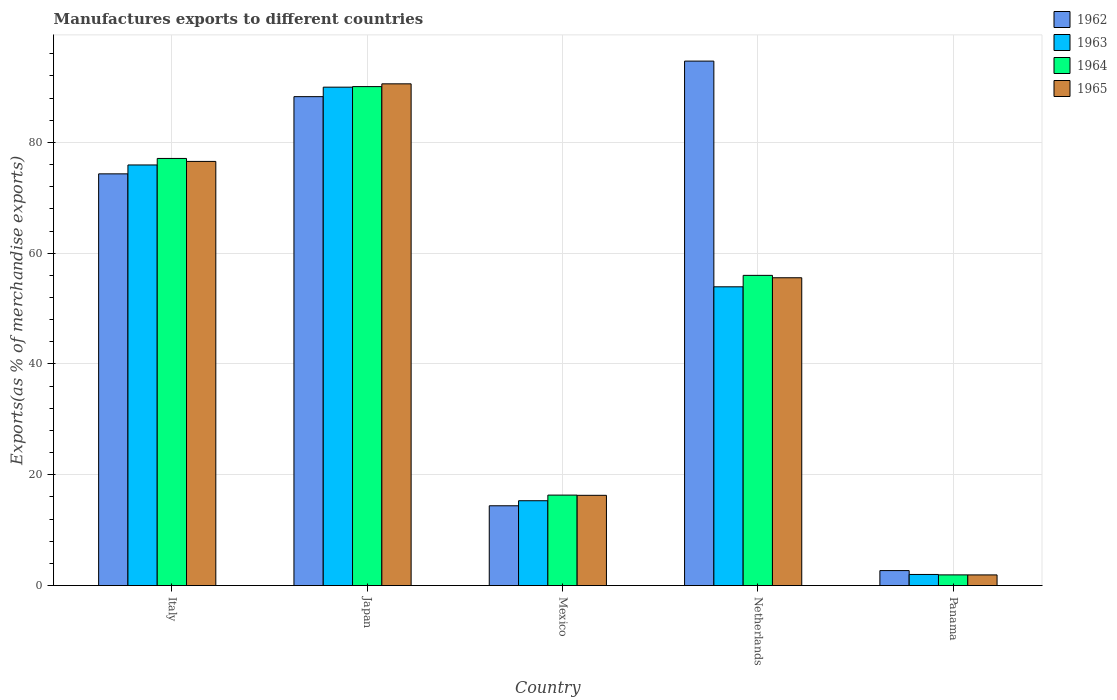How many different coloured bars are there?
Your answer should be very brief. 4. How many groups of bars are there?
Ensure brevity in your answer.  5. Are the number of bars per tick equal to the number of legend labels?
Provide a short and direct response. Yes. How many bars are there on the 4th tick from the right?
Keep it short and to the point. 4. What is the label of the 3rd group of bars from the left?
Provide a short and direct response. Mexico. What is the percentage of exports to different countries in 1965 in Mexico?
Offer a very short reply. 16.29. Across all countries, what is the maximum percentage of exports to different countries in 1964?
Keep it short and to the point. 90.07. Across all countries, what is the minimum percentage of exports to different countries in 1963?
Make the answer very short. 2. In which country was the percentage of exports to different countries in 1965 maximum?
Give a very brief answer. Japan. In which country was the percentage of exports to different countries in 1962 minimum?
Make the answer very short. Panama. What is the total percentage of exports to different countries in 1965 in the graph?
Your answer should be very brief. 240.92. What is the difference between the percentage of exports to different countries in 1964 in Mexico and that in Panama?
Provide a short and direct response. 14.4. What is the difference between the percentage of exports to different countries in 1964 in Panama and the percentage of exports to different countries in 1962 in Japan?
Your response must be concise. -86.33. What is the average percentage of exports to different countries in 1962 per country?
Your answer should be compact. 54.87. What is the difference between the percentage of exports to different countries of/in 1963 and percentage of exports to different countries of/in 1965 in Panama?
Your answer should be compact. 0.08. What is the ratio of the percentage of exports to different countries in 1964 in Netherlands to that in Panama?
Make the answer very short. 29.06. Is the percentage of exports to different countries in 1964 in Italy less than that in Japan?
Ensure brevity in your answer.  Yes. What is the difference between the highest and the second highest percentage of exports to different countries in 1965?
Ensure brevity in your answer.  14.01. What is the difference between the highest and the lowest percentage of exports to different countries in 1964?
Give a very brief answer. 88.15. Is the sum of the percentage of exports to different countries in 1962 in Italy and Japan greater than the maximum percentage of exports to different countries in 1963 across all countries?
Offer a terse response. Yes. Is it the case that in every country, the sum of the percentage of exports to different countries in 1963 and percentage of exports to different countries in 1962 is greater than the sum of percentage of exports to different countries in 1965 and percentage of exports to different countries in 1964?
Your answer should be compact. No. What does the 1st bar from the right in Panama represents?
Provide a short and direct response. 1965. How many bars are there?
Offer a terse response. 20. What is the difference between two consecutive major ticks on the Y-axis?
Keep it short and to the point. 20. Does the graph contain any zero values?
Offer a terse response. No. Does the graph contain grids?
Keep it short and to the point. Yes. Where does the legend appear in the graph?
Provide a short and direct response. Top right. How many legend labels are there?
Ensure brevity in your answer.  4. How are the legend labels stacked?
Keep it short and to the point. Vertical. What is the title of the graph?
Your answer should be very brief. Manufactures exports to different countries. What is the label or title of the Y-axis?
Your answer should be compact. Exports(as % of merchandise exports). What is the Exports(as % of merchandise exports) in 1962 in Italy?
Ensure brevity in your answer.  74.32. What is the Exports(as % of merchandise exports) in 1963 in Italy?
Give a very brief answer. 75.93. What is the Exports(as % of merchandise exports) of 1964 in Italy?
Keep it short and to the point. 77.1. What is the Exports(as % of merchandise exports) of 1965 in Italy?
Provide a short and direct response. 76.57. What is the Exports(as % of merchandise exports) of 1962 in Japan?
Provide a succinct answer. 88.26. What is the Exports(as % of merchandise exports) of 1963 in Japan?
Ensure brevity in your answer.  89.97. What is the Exports(as % of merchandise exports) of 1964 in Japan?
Make the answer very short. 90.07. What is the Exports(as % of merchandise exports) in 1965 in Japan?
Keep it short and to the point. 90.57. What is the Exports(as % of merchandise exports) in 1962 in Mexico?
Make the answer very short. 14.4. What is the Exports(as % of merchandise exports) in 1963 in Mexico?
Your answer should be compact. 15.31. What is the Exports(as % of merchandise exports) in 1964 in Mexico?
Provide a short and direct response. 16.33. What is the Exports(as % of merchandise exports) of 1965 in Mexico?
Make the answer very short. 16.29. What is the Exports(as % of merchandise exports) of 1962 in Netherlands?
Make the answer very short. 94.68. What is the Exports(as % of merchandise exports) of 1963 in Netherlands?
Provide a succinct answer. 53.93. What is the Exports(as % of merchandise exports) of 1964 in Netherlands?
Provide a short and direct response. 56. What is the Exports(as % of merchandise exports) of 1965 in Netherlands?
Ensure brevity in your answer.  55.57. What is the Exports(as % of merchandise exports) of 1962 in Panama?
Give a very brief answer. 2.7. What is the Exports(as % of merchandise exports) in 1963 in Panama?
Ensure brevity in your answer.  2. What is the Exports(as % of merchandise exports) of 1964 in Panama?
Provide a short and direct response. 1.93. What is the Exports(as % of merchandise exports) of 1965 in Panama?
Provide a succinct answer. 1.92. Across all countries, what is the maximum Exports(as % of merchandise exports) of 1962?
Offer a very short reply. 94.68. Across all countries, what is the maximum Exports(as % of merchandise exports) in 1963?
Keep it short and to the point. 89.97. Across all countries, what is the maximum Exports(as % of merchandise exports) in 1964?
Your answer should be very brief. 90.07. Across all countries, what is the maximum Exports(as % of merchandise exports) in 1965?
Your answer should be very brief. 90.57. Across all countries, what is the minimum Exports(as % of merchandise exports) in 1962?
Offer a very short reply. 2.7. Across all countries, what is the minimum Exports(as % of merchandise exports) of 1963?
Your response must be concise. 2. Across all countries, what is the minimum Exports(as % of merchandise exports) in 1964?
Your answer should be very brief. 1.93. Across all countries, what is the minimum Exports(as % of merchandise exports) of 1965?
Your response must be concise. 1.92. What is the total Exports(as % of merchandise exports) of 1962 in the graph?
Your response must be concise. 274.37. What is the total Exports(as % of merchandise exports) of 1963 in the graph?
Give a very brief answer. 237.15. What is the total Exports(as % of merchandise exports) in 1964 in the graph?
Provide a succinct answer. 241.43. What is the total Exports(as % of merchandise exports) in 1965 in the graph?
Provide a succinct answer. 240.92. What is the difference between the Exports(as % of merchandise exports) of 1962 in Italy and that in Japan?
Keep it short and to the point. -13.94. What is the difference between the Exports(as % of merchandise exports) of 1963 in Italy and that in Japan?
Provide a short and direct response. -14.04. What is the difference between the Exports(as % of merchandise exports) in 1964 in Italy and that in Japan?
Provide a succinct answer. -12.97. What is the difference between the Exports(as % of merchandise exports) in 1965 in Italy and that in Japan?
Your response must be concise. -14.01. What is the difference between the Exports(as % of merchandise exports) of 1962 in Italy and that in Mexico?
Offer a terse response. 59.92. What is the difference between the Exports(as % of merchandise exports) of 1963 in Italy and that in Mexico?
Provide a short and direct response. 60.61. What is the difference between the Exports(as % of merchandise exports) in 1964 in Italy and that in Mexico?
Provide a succinct answer. 60.77. What is the difference between the Exports(as % of merchandise exports) of 1965 in Italy and that in Mexico?
Make the answer very short. 60.28. What is the difference between the Exports(as % of merchandise exports) in 1962 in Italy and that in Netherlands?
Keep it short and to the point. -20.36. What is the difference between the Exports(as % of merchandise exports) in 1963 in Italy and that in Netherlands?
Provide a succinct answer. 22. What is the difference between the Exports(as % of merchandise exports) of 1964 in Italy and that in Netherlands?
Provide a succinct answer. 21.11. What is the difference between the Exports(as % of merchandise exports) of 1965 in Italy and that in Netherlands?
Provide a succinct answer. 21. What is the difference between the Exports(as % of merchandise exports) of 1962 in Italy and that in Panama?
Keep it short and to the point. 71.62. What is the difference between the Exports(as % of merchandise exports) of 1963 in Italy and that in Panama?
Give a very brief answer. 73.92. What is the difference between the Exports(as % of merchandise exports) of 1964 in Italy and that in Panama?
Your response must be concise. 75.18. What is the difference between the Exports(as % of merchandise exports) of 1965 in Italy and that in Panama?
Make the answer very short. 74.64. What is the difference between the Exports(as % of merchandise exports) in 1962 in Japan and that in Mexico?
Your answer should be very brief. 73.86. What is the difference between the Exports(as % of merchandise exports) in 1963 in Japan and that in Mexico?
Provide a succinct answer. 74.66. What is the difference between the Exports(as % of merchandise exports) of 1964 in Japan and that in Mexico?
Your answer should be compact. 73.74. What is the difference between the Exports(as % of merchandise exports) of 1965 in Japan and that in Mexico?
Give a very brief answer. 74.28. What is the difference between the Exports(as % of merchandise exports) in 1962 in Japan and that in Netherlands?
Give a very brief answer. -6.42. What is the difference between the Exports(as % of merchandise exports) of 1963 in Japan and that in Netherlands?
Your answer should be compact. 36.04. What is the difference between the Exports(as % of merchandise exports) in 1964 in Japan and that in Netherlands?
Make the answer very short. 34.07. What is the difference between the Exports(as % of merchandise exports) in 1965 in Japan and that in Netherlands?
Your response must be concise. 35.01. What is the difference between the Exports(as % of merchandise exports) in 1962 in Japan and that in Panama?
Give a very brief answer. 85.56. What is the difference between the Exports(as % of merchandise exports) of 1963 in Japan and that in Panama?
Ensure brevity in your answer.  87.97. What is the difference between the Exports(as % of merchandise exports) in 1964 in Japan and that in Panama?
Your response must be concise. 88.15. What is the difference between the Exports(as % of merchandise exports) of 1965 in Japan and that in Panama?
Keep it short and to the point. 88.65. What is the difference between the Exports(as % of merchandise exports) of 1962 in Mexico and that in Netherlands?
Your response must be concise. -80.27. What is the difference between the Exports(as % of merchandise exports) in 1963 in Mexico and that in Netherlands?
Offer a terse response. -38.62. What is the difference between the Exports(as % of merchandise exports) in 1964 in Mexico and that in Netherlands?
Offer a very short reply. -39.67. What is the difference between the Exports(as % of merchandise exports) in 1965 in Mexico and that in Netherlands?
Your answer should be compact. -39.28. What is the difference between the Exports(as % of merchandise exports) in 1962 in Mexico and that in Panama?
Keep it short and to the point. 11.7. What is the difference between the Exports(as % of merchandise exports) of 1963 in Mexico and that in Panama?
Offer a very short reply. 13.31. What is the difference between the Exports(as % of merchandise exports) in 1964 in Mexico and that in Panama?
Provide a succinct answer. 14.4. What is the difference between the Exports(as % of merchandise exports) in 1965 in Mexico and that in Panama?
Ensure brevity in your answer.  14.37. What is the difference between the Exports(as % of merchandise exports) in 1962 in Netherlands and that in Panama?
Provide a succinct answer. 91.97. What is the difference between the Exports(as % of merchandise exports) of 1963 in Netherlands and that in Panama?
Your answer should be very brief. 51.93. What is the difference between the Exports(as % of merchandise exports) in 1964 in Netherlands and that in Panama?
Offer a terse response. 54.07. What is the difference between the Exports(as % of merchandise exports) of 1965 in Netherlands and that in Panama?
Your answer should be very brief. 53.64. What is the difference between the Exports(as % of merchandise exports) in 1962 in Italy and the Exports(as % of merchandise exports) in 1963 in Japan?
Offer a very short reply. -15.65. What is the difference between the Exports(as % of merchandise exports) in 1962 in Italy and the Exports(as % of merchandise exports) in 1964 in Japan?
Give a very brief answer. -15.75. What is the difference between the Exports(as % of merchandise exports) in 1962 in Italy and the Exports(as % of merchandise exports) in 1965 in Japan?
Ensure brevity in your answer.  -16.25. What is the difference between the Exports(as % of merchandise exports) of 1963 in Italy and the Exports(as % of merchandise exports) of 1964 in Japan?
Give a very brief answer. -14.14. What is the difference between the Exports(as % of merchandise exports) of 1963 in Italy and the Exports(as % of merchandise exports) of 1965 in Japan?
Ensure brevity in your answer.  -14.64. What is the difference between the Exports(as % of merchandise exports) of 1964 in Italy and the Exports(as % of merchandise exports) of 1965 in Japan?
Provide a succinct answer. -13.47. What is the difference between the Exports(as % of merchandise exports) in 1962 in Italy and the Exports(as % of merchandise exports) in 1963 in Mexico?
Give a very brief answer. 59.01. What is the difference between the Exports(as % of merchandise exports) in 1962 in Italy and the Exports(as % of merchandise exports) in 1964 in Mexico?
Keep it short and to the point. 57.99. What is the difference between the Exports(as % of merchandise exports) in 1962 in Italy and the Exports(as % of merchandise exports) in 1965 in Mexico?
Ensure brevity in your answer.  58.03. What is the difference between the Exports(as % of merchandise exports) in 1963 in Italy and the Exports(as % of merchandise exports) in 1964 in Mexico?
Your answer should be very brief. 59.6. What is the difference between the Exports(as % of merchandise exports) of 1963 in Italy and the Exports(as % of merchandise exports) of 1965 in Mexico?
Make the answer very short. 59.64. What is the difference between the Exports(as % of merchandise exports) in 1964 in Italy and the Exports(as % of merchandise exports) in 1965 in Mexico?
Your answer should be very brief. 60.81. What is the difference between the Exports(as % of merchandise exports) in 1962 in Italy and the Exports(as % of merchandise exports) in 1963 in Netherlands?
Offer a terse response. 20.39. What is the difference between the Exports(as % of merchandise exports) in 1962 in Italy and the Exports(as % of merchandise exports) in 1964 in Netherlands?
Your response must be concise. 18.32. What is the difference between the Exports(as % of merchandise exports) of 1962 in Italy and the Exports(as % of merchandise exports) of 1965 in Netherlands?
Keep it short and to the point. 18.76. What is the difference between the Exports(as % of merchandise exports) in 1963 in Italy and the Exports(as % of merchandise exports) in 1964 in Netherlands?
Your answer should be compact. 19.93. What is the difference between the Exports(as % of merchandise exports) of 1963 in Italy and the Exports(as % of merchandise exports) of 1965 in Netherlands?
Ensure brevity in your answer.  20.36. What is the difference between the Exports(as % of merchandise exports) of 1964 in Italy and the Exports(as % of merchandise exports) of 1965 in Netherlands?
Offer a very short reply. 21.54. What is the difference between the Exports(as % of merchandise exports) in 1962 in Italy and the Exports(as % of merchandise exports) in 1963 in Panama?
Ensure brevity in your answer.  72.32. What is the difference between the Exports(as % of merchandise exports) in 1962 in Italy and the Exports(as % of merchandise exports) in 1964 in Panama?
Your answer should be compact. 72.39. What is the difference between the Exports(as % of merchandise exports) in 1962 in Italy and the Exports(as % of merchandise exports) in 1965 in Panama?
Your answer should be very brief. 72.4. What is the difference between the Exports(as % of merchandise exports) in 1963 in Italy and the Exports(as % of merchandise exports) in 1964 in Panama?
Make the answer very short. 74. What is the difference between the Exports(as % of merchandise exports) in 1963 in Italy and the Exports(as % of merchandise exports) in 1965 in Panama?
Your response must be concise. 74.01. What is the difference between the Exports(as % of merchandise exports) of 1964 in Italy and the Exports(as % of merchandise exports) of 1965 in Panama?
Offer a very short reply. 75.18. What is the difference between the Exports(as % of merchandise exports) of 1962 in Japan and the Exports(as % of merchandise exports) of 1963 in Mexico?
Offer a very short reply. 72.95. What is the difference between the Exports(as % of merchandise exports) in 1962 in Japan and the Exports(as % of merchandise exports) in 1964 in Mexico?
Your response must be concise. 71.93. What is the difference between the Exports(as % of merchandise exports) of 1962 in Japan and the Exports(as % of merchandise exports) of 1965 in Mexico?
Keep it short and to the point. 71.97. What is the difference between the Exports(as % of merchandise exports) of 1963 in Japan and the Exports(as % of merchandise exports) of 1964 in Mexico?
Your response must be concise. 73.64. What is the difference between the Exports(as % of merchandise exports) in 1963 in Japan and the Exports(as % of merchandise exports) in 1965 in Mexico?
Give a very brief answer. 73.68. What is the difference between the Exports(as % of merchandise exports) in 1964 in Japan and the Exports(as % of merchandise exports) in 1965 in Mexico?
Your answer should be very brief. 73.78. What is the difference between the Exports(as % of merchandise exports) of 1962 in Japan and the Exports(as % of merchandise exports) of 1963 in Netherlands?
Give a very brief answer. 34.33. What is the difference between the Exports(as % of merchandise exports) of 1962 in Japan and the Exports(as % of merchandise exports) of 1964 in Netherlands?
Provide a short and direct response. 32.26. What is the difference between the Exports(as % of merchandise exports) of 1962 in Japan and the Exports(as % of merchandise exports) of 1965 in Netherlands?
Your answer should be compact. 32.69. What is the difference between the Exports(as % of merchandise exports) in 1963 in Japan and the Exports(as % of merchandise exports) in 1964 in Netherlands?
Provide a succinct answer. 33.97. What is the difference between the Exports(as % of merchandise exports) of 1963 in Japan and the Exports(as % of merchandise exports) of 1965 in Netherlands?
Your answer should be very brief. 34.41. What is the difference between the Exports(as % of merchandise exports) in 1964 in Japan and the Exports(as % of merchandise exports) in 1965 in Netherlands?
Your answer should be very brief. 34.51. What is the difference between the Exports(as % of merchandise exports) in 1962 in Japan and the Exports(as % of merchandise exports) in 1963 in Panama?
Offer a very short reply. 86.26. What is the difference between the Exports(as % of merchandise exports) of 1962 in Japan and the Exports(as % of merchandise exports) of 1964 in Panama?
Keep it short and to the point. 86.33. What is the difference between the Exports(as % of merchandise exports) of 1962 in Japan and the Exports(as % of merchandise exports) of 1965 in Panama?
Your response must be concise. 86.34. What is the difference between the Exports(as % of merchandise exports) in 1963 in Japan and the Exports(as % of merchandise exports) in 1964 in Panama?
Provide a succinct answer. 88.05. What is the difference between the Exports(as % of merchandise exports) of 1963 in Japan and the Exports(as % of merchandise exports) of 1965 in Panama?
Your answer should be compact. 88.05. What is the difference between the Exports(as % of merchandise exports) of 1964 in Japan and the Exports(as % of merchandise exports) of 1965 in Panama?
Your answer should be compact. 88.15. What is the difference between the Exports(as % of merchandise exports) in 1962 in Mexico and the Exports(as % of merchandise exports) in 1963 in Netherlands?
Provide a short and direct response. -39.53. What is the difference between the Exports(as % of merchandise exports) of 1962 in Mexico and the Exports(as % of merchandise exports) of 1964 in Netherlands?
Your answer should be compact. -41.59. What is the difference between the Exports(as % of merchandise exports) of 1962 in Mexico and the Exports(as % of merchandise exports) of 1965 in Netherlands?
Your response must be concise. -41.16. What is the difference between the Exports(as % of merchandise exports) of 1963 in Mexico and the Exports(as % of merchandise exports) of 1964 in Netherlands?
Your answer should be compact. -40.68. What is the difference between the Exports(as % of merchandise exports) of 1963 in Mexico and the Exports(as % of merchandise exports) of 1965 in Netherlands?
Your answer should be compact. -40.25. What is the difference between the Exports(as % of merchandise exports) of 1964 in Mexico and the Exports(as % of merchandise exports) of 1965 in Netherlands?
Your response must be concise. -39.24. What is the difference between the Exports(as % of merchandise exports) of 1962 in Mexico and the Exports(as % of merchandise exports) of 1963 in Panama?
Ensure brevity in your answer.  12.4. What is the difference between the Exports(as % of merchandise exports) of 1962 in Mexico and the Exports(as % of merchandise exports) of 1964 in Panama?
Offer a terse response. 12.48. What is the difference between the Exports(as % of merchandise exports) of 1962 in Mexico and the Exports(as % of merchandise exports) of 1965 in Panama?
Your answer should be very brief. 12.48. What is the difference between the Exports(as % of merchandise exports) of 1963 in Mexico and the Exports(as % of merchandise exports) of 1964 in Panama?
Ensure brevity in your answer.  13.39. What is the difference between the Exports(as % of merchandise exports) in 1963 in Mexico and the Exports(as % of merchandise exports) in 1965 in Panama?
Make the answer very short. 13.39. What is the difference between the Exports(as % of merchandise exports) in 1964 in Mexico and the Exports(as % of merchandise exports) in 1965 in Panama?
Provide a succinct answer. 14.41. What is the difference between the Exports(as % of merchandise exports) of 1962 in Netherlands and the Exports(as % of merchandise exports) of 1963 in Panama?
Make the answer very short. 92.67. What is the difference between the Exports(as % of merchandise exports) in 1962 in Netherlands and the Exports(as % of merchandise exports) in 1964 in Panama?
Your answer should be compact. 92.75. What is the difference between the Exports(as % of merchandise exports) in 1962 in Netherlands and the Exports(as % of merchandise exports) in 1965 in Panama?
Give a very brief answer. 92.75. What is the difference between the Exports(as % of merchandise exports) in 1963 in Netherlands and the Exports(as % of merchandise exports) in 1964 in Panama?
Keep it short and to the point. 52. What is the difference between the Exports(as % of merchandise exports) in 1963 in Netherlands and the Exports(as % of merchandise exports) in 1965 in Panama?
Make the answer very short. 52.01. What is the difference between the Exports(as % of merchandise exports) in 1964 in Netherlands and the Exports(as % of merchandise exports) in 1965 in Panama?
Offer a very short reply. 54.07. What is the average Exports(as % of merchandise exports) of 1962 per country?
Your response must be concise. 54.87. What is the average Exports(as % of merchandise exports) of 1963 per country?
Your answer should be compact. 47.43. What is the average Exports(as % of merchandise exports) of 1964 per country?
Ensure brevity in your answer.  48.29. What is the average Exports(as % of merchandise exports) in 1965 per country?
Offer a very short reply. 48.18. What is the difference between the Exports(as % of merchandise exports) of 1962 and Exports(as % of merchandise exports) of 1963 in Italy?
Give a very brief answer. -1.61. What is the difference between the Exports(as % of merchandise exports) in 1962 and Exports(as % of merchandise exports) in 1964 in Italy?
Offer a terse response. -2.78. What is the difference between the Exports(as % of merchandise exports) in 1962 and Exports(as % of merchandise exports) in 1965 in Italy?
Offer a very short reply. -2.25. What is the difference between the Exports(as % of merchandise exports) of 1963 and Exports(as % of merchandise exports) of 1964 in Italy?
Offer a very short reply. -1.17. What is the difference between the Exports(as % of merchandise exports) in 1963 and Exports(as % of merchandise exports) in 1965 in Italy?
Make the answer very short. -0.64. What is the difference between the Exports(as % of merchandise exports) in 1964 and Exports(as % of merchandise exports) in 1965 in Italy?
Provide a short and direct response. 0.54. What is the difference between the Exports(as % of merchandise exports) of 1962 and Exports(as % of merchandise exports) of 1963 in Japan?
Give a very brief answer. -1.71. What is the difference between the Exports(as % of merchandise exports) of 1962 and Exports(as % of merchandise exports) of 1964 in Japan?
Provide a short and direct response. -1.81. What is the difference between the Exports(as % of merchandise exports) of 1962 and Exports(as % of merchandise exports) of 1965 in Japan?
Provide a short and direct response. -2.31. What is the difference between the Exports(as % of merchandise exports) of 1963 and Exports(as % of merchandise exports) of 1964 in Japan?
Offer a terse response. -0.1. What is the difference between the Exports(as % of merchandise exports) in 1963 and Exports(as % of merchandise exports) in 1965 in Japan?
Offer a very short reply. -0.6. What is the difference between the Exports(as % of merchandise exports) of 1964 and Exports(as % of merchandise exports) of 1965 in Japan?
Offer a terse response. -0.5. What is the difference between the Exports(as % of merchandise exports) of 1962 and Exports(as % of merchandise exports) of 1963 in Mexico?
Offer a terse response. -0.91. What is the difference between the Exports(as % of merchandise exports) of 1962 and Exports(as % of merchandise exports) of 1964 in Mexico?
Your answer should be very brief. -1.93. What is the difference between the Exports(as % of merchandise exports) of 1962 and Exports(as % of merchandise exports) of 1965 in Mexico?
Your answer should be very brief. -1.89. What is the difference between the Exports(as % of merchandise exports) in 1963 and Exports(as % of merchandise exports) in 1964 in Mexico?
Provide a short and direct response. -1.02. What is the difference between the Exports(as % of merchandise exports) of 1963 and Exports(as % of merchandise exports) of 1965 in Mexico?
Offer a very short reply. -0.98. What is the difference between the Exports(as % of merchandise exports) in 1964 and Exports(as % of merchandise exports) in 1965 in Mexico?
Your answer should be compact. 0.04. What is the difference between the Exports(as % of merchandise exports) in 1962 and Exports(as % of merchandise exports) in 1963 in Netherlands?
Offer a terse response. 40.75. What is the difference between the Exports(as % of merchandise exports) in 1962 and Exports(as % of merchandise exports) in 1964 in Netherlands?
Provide a short and direct response. 38.68. What is the difference between the Exports(as % of merchandise exports) in 1962 and Exports(as % of merchandise exports) in 1965 in Netherlands?
Your response must be concise. 39.11. What is the difference between the Exports(as % of merchandise exports) of 1963 and Exports(as % of merchandise exports) of 1964 in Netherlands?
Your answer should be compact. -2.07. What is the difference between the Exports(as % of merchandise exports) of 1963 and Exports(as % of merchandise exports) of 1965 in Netherlands?
Give a very brief answer. -1.64. What is the difference between the Exports(as % of merchandise exports) of 1964 and Exports(as % of merchandise exports) of 1965 in Netherlands?
Make the answer very short. 0.43. What is the difference between the Exports(as % of merchandise exports) of 1962 and Exports(as % of merchandise exports) of 1963 in Panama?
Provide a succinct answer. 0.7. What is the difference between the Exports(as % of merchandise exports) of 1962 and Exports(as % of merchandise exports) of 1964 in Panama?
Provide a short and direct response. 0.78. What is the difference between the Exports(as % of merchandise exports) of 1962 and Exports(as % of merchandise exports) of 1965 in Panama?
Your response must be concise. 0.78. What is the difference between the Exports(as % of merchandise exports) in 1963 and Exports(as % of merchandise exports) in 1964 in Panama?
Offer a terse response. 0.08. What is the difference between the Exports(as % of merchandise exports) of 1963 and Exports(as % of merchandise exports) of 1965 in Panama?
Provide a short and direct response. 0.08. What is the difference between the Exports(as % of merchandise exports) of 1964 and Exports(as % of merchandise exports) of 1965 in Panama?
Offer a very short reply. 0. What is the ratio of the Exports(as % of merchandise exports) of 1962 in Italy to that in Japan?
Your answer should be compact. 0.84. What is the ratio of the Exports(as % of merchandise exports) in 1963 in Italy to that in Japan?
Offer a terse response. 0.84. What is the ratio of the Exports(as % of merchandise exports) of 1964 in Italy to that in Japan?
Ensure brevity in your answer.  0.86. What is the ratio of the Exports(as % of merchandise exports) of 1965 in Italy to that in Japan?
Offer a very short reply. 0.85. What is the ratio of the Exports(as % of merchandise exports) of 1962 in Italy to that in Mexico?
Offer a terse response. 5.16. What is the ratio of the Exports(as % of merchandise exports) of 1963 in Italy to that in Mexico?
Provide a short and direct response. 4.96. What is the ratio of the Exports(as % of merchandise exports) in 1964 in Italy to that in Mexico?
Provide a succinct answer. 4.72. What is the ratio of the Exports(as % of merchandise exports) in 1965 in Italy to that in Mexico?
Offer a very short reply. 4.7. What is the ratio of the Exports(as % of merchandise exports) of 1962 in Italy to that in Netherlands?
Your response must be concise. 0.79. What is the ratio of the Exports(as % of merchandise exports) of 1963 in Italy to that in Netherlands?
Ensure brevity in your answer.  1.41. What is the ratio of the Exports(as % of merchandise exports) of 1964 in Italy to that in Netherlands?
Provide a succinct answer. 1.38. What is the ratio of the Exports(as % of merchandise exports) of 1965 in Italy to that in Netherlands?
Provide a succinct answer. 1.38. What is the ratio of the Exports(as % of merchandise exports) in 1962 in Italy to that in Panama?
Make the answer very short. 27.49. What is the ratio of the Exports(as % of merchandise exports) in 1963 in Italy to that in Panama?
Provide a succinct answer. 37.88. What is the ratio of the Exports(as % of merchandise exports) in 1964 in Italy to that in Panama?
Offer a very short reply. 40.02. What is the ratio of the Exports(as % of merchandise exports) in 1965 in Italy to that in Panama?
Your answer should be very brief. 39.82. What is the ratio of the Exports(as % of merchandise exports) in 1962 in Japan to that in Mexico?
Your answer should be very brief. 6.13. What is the ratio of the Exports(as % of merchandise exports) of 1963 in Japan to that in Mexico?
Give a very brief answer. 5.88. What is the ratio of the Exports(as % of merchandise exports) of 1964 in Japan to that in Mexico?
Make the answer very short. 5.52. What is the ratio of the Exports(as % of merchandise exports) of 1965 in Japan to that in Mexico?
Provide a short and direct response. 5.56. What is the ratio of the Exports(as % of merchandise exports) of 1962 in Japan to that in Netherlands?
Give a very brief answer. 0.93. What is the ratio of the Exports(as % of merchandise exports) in 1963 in Japan to that in Netherlands?
Provide a short and direct response. 1.67. What is the ratio of the Exports(as % of merchandise exports) in 1964 in Japan to that in Netherlands?
Your answer should be compact. 1.61. What is the ratio of the Exports(as % of merchandise exports) in 1965 in Japan to that in Netherlands?
Keep it short and to the point. 1.63. What is the ratio of the Exports(as % of merchandise exports) of 1962 in Japan to that in Panama?
Ensure brevity in your answer.  32.64. What is the ratio of the Exports(as % of merchandise exports) in 1963 in Japan to that in Panama?
Make the answer very short. 44.89. What is the ratio of the Exports(as % of merchandise exports) of 1964 in Japan to that in Panama?
Offer a terse response. 46.75. What is the ratio of the Exports(as % of merchandise exports) of 1965 in Japan to that in Panama?
Provide a succinct answer. 47.1. What is the ratio of the Exports(as % of merchandise exports) in 1962 in Mexico to that in Netherlands?
Provide a succinct answer. 0.15. What is the ratio of the Exports(as % of merchandise exports) of 1963 in Mexico to that in Netherlands?
Offer a terse response. 0.28. What is the ratio of the Exports(as % of merchandise exports) of 1964 in Mexico to that in Netherlands?
Provide a succinct answer. 0.29. What is the ratio of the Exports(as % of merchandise exports) of 1965 in Mexico to that in Netherlands?
Give a very brief answer. 0.29. What is the ratio of the Exports(as % of merchandise exports) of 1962 in Mexico to that in Panama?
Ensure brevity in your answer.  5.33. What is the ratio of the Exports(as % of merchandise exports) in 1963 in Mexico to that in Panama?
Offer a very short reply. 7.64. What is the ratio of the Exports(as % of merchandise exports) in 1964 in Mexico to that in Panama?
Your answer should be compact. 8.48. What is the ratio of the Exports(as % of merchandise exports) of 1965 in Mexico to that in Panama?
Provide a short and direct response. 8.47. What is the ratio of the Exports(as % of merchandise exports) of 1962 in Netherlands to that in Panama?
Ensure brevity in your answer.  35.02. What is the ratio of the Exports(as % of merchandise exports) of 1963 in Netherlands to that in Panama?
Offer a terse response. 26.91. What is the ratio of the Exports(as % of merchandise exports) of 1964 in Netherlands to that in Panama?
Provide a short and direct response. 29.06. What is the ratio of the Exports(as % of merchandise exports) of 1965 in Netherlands to that in Panama?
Provide a succinct answer. 28.9. What is the difference between the highest and the second highest Exports(as % of merchandise exports) of 1962?
Provide a short and direct response. 6.42. What is the difference between the highest and the second highest Exports(as % of merchandise exports) in 1963?
Provide a succinct answer. 14.04. What is the difference between the highest and the second highest Exports(as % of merchandise exports) of 1964?
Your answer should be compact. 12.97. What is the difference between the highest and the second highest Exports(as % of merchandise exports) in 1965?
Your response must be concise. 14.01. What is the difference between the highest and the lowest Exports(as % of merchandise exports) of 1962?
Provide a succinct answer. 91.97. What is the difference between the highest and the lowest Exports(as % of merchandise exports) of 1963?
Provide a succinct answer. 87.97. What is the difference between the highest and the lowest Exports(as % of merchandise exports) in 1964?
Give a very brief answer. 88.15. What is the difference between the highest and the lowest Exports(as % of merchandise exports) of 1965?
Your answer should be compact. 88.65. 